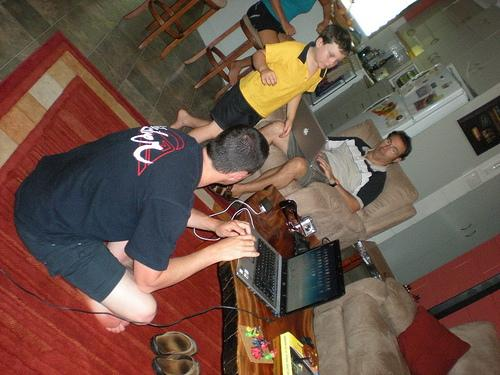What company made the silver laptop the man on the couch is using? apple 